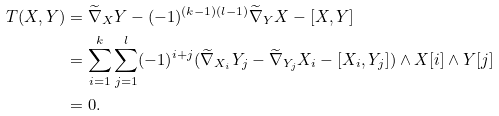Convert formula to latex. <formula><loc_0><loc_0><loc_500><loc_500>T ( X , Y ) & = \widetilde { \nabla } _ { X } Y - ( - 1 ) ^ { ( k - 1 ) ( l - 1 ) } \widetilde { \nabla } _ { Y } X - [ X , Y ] \\ & = \sum _ { i = 1 } ^ { k } \sum _ { j = 1 } ^ { l } ( - 1 ) ^ { i + j } ( \widetilde { \nabla } _ { X _ { i } } Y _ { j } - \widetilde { \nabla } _ { Y _ { j } } X _ { i } - [ X _ { i } , Y _ { j } ] ) \wedge X [ i ] \wedge Y [ j ] \\ & = 0 .</formula> 